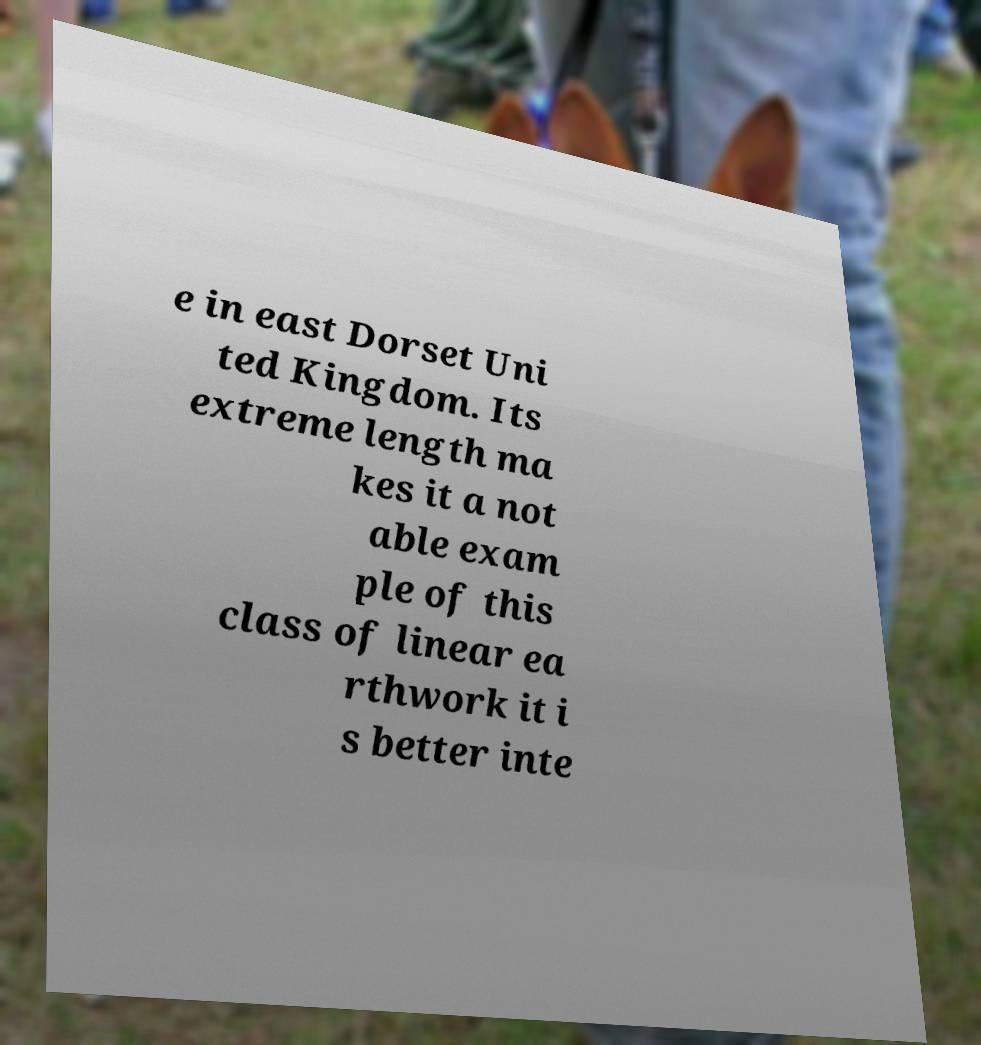Please identify and transcribe the text found in this image. e in east Dorset Uni ted Kingdom. Its extreme length ma kes it a not able exam ple of this class of linear ea rthwork it i s better inte 